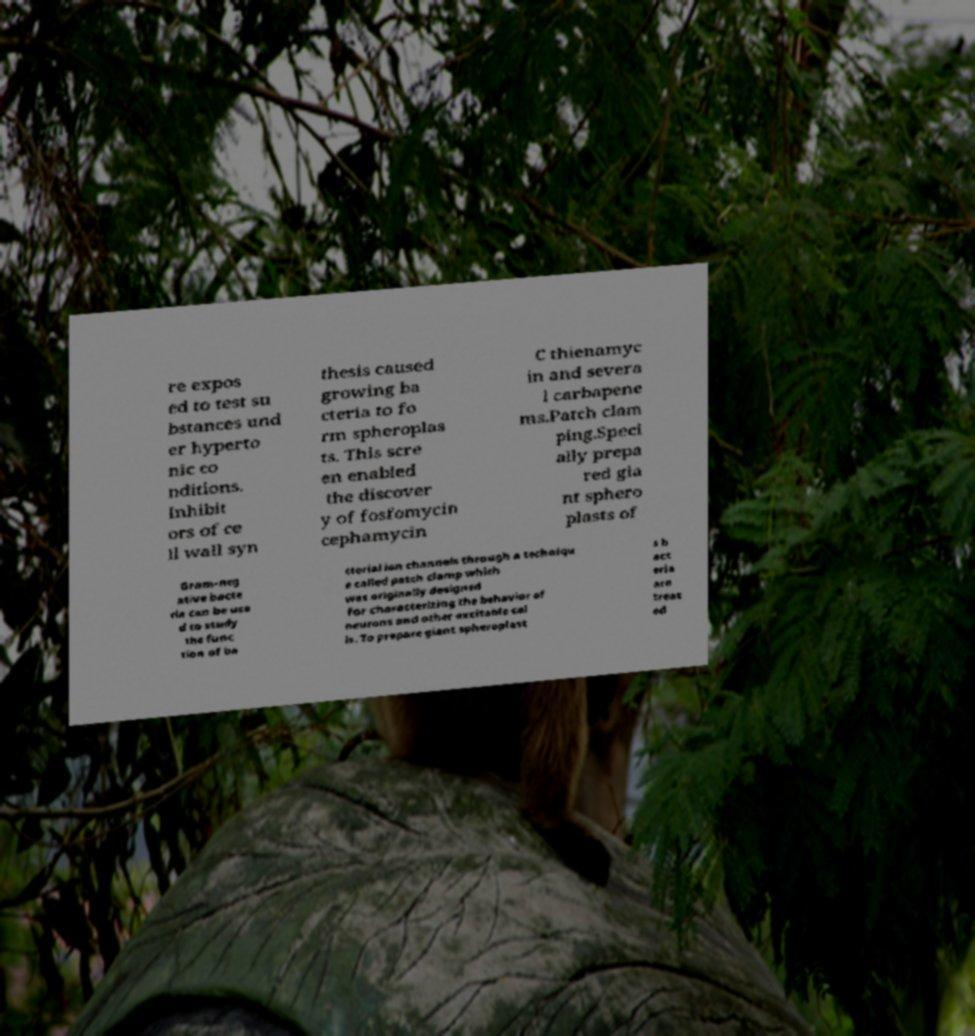I need the written content from this picture converted into text. Can you do that? re expos ed to test su bstances und er hyperto nic co nditions. Inhibit ors of ce ll wall syn thesis caused growing ba cteria to fo rm spheroplas ts. This scre en enabled the discover y of fosfomycin cephamycin C thienamyc in and severa l carbapene ms.Patch clam ping.Speci ally prepa red gia nt sphero plasts of Gram-neg ative bacte ria can be use d to study the func tion of ba cterial ion channels through a techniqu e called patch clamp which was originally designed for characterizing the behavior of neurons and other excitable cel ls. To prepare giant spheroplast s b act eria are treat ed 